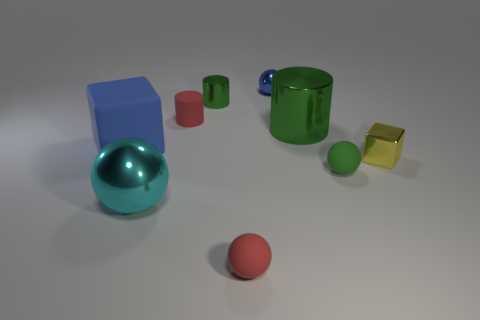Does the cube that is left of the yellow cube have the same size as the big cyan metal ball? The cube to the left of the yellow cube is smaller in size compared to the large cyan metal ball. While visually the cube might seem comparable in one dimension, the ball's diameter is larger, making its overall volume greater. 